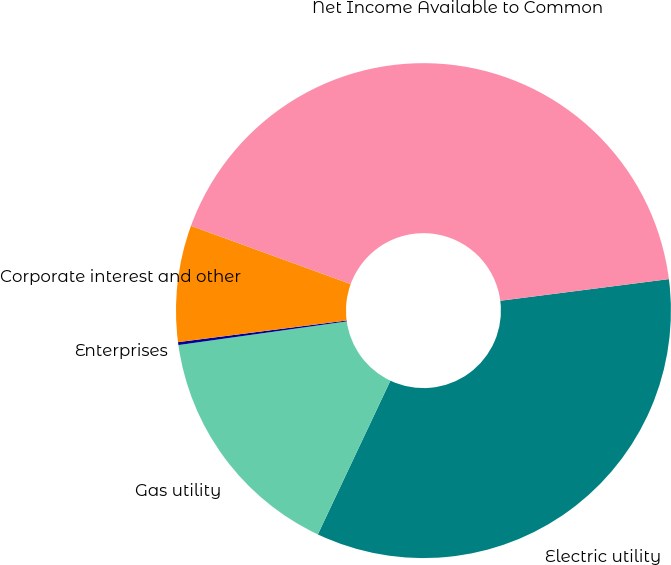Convert chart to OTSL. <chart><loc_0><loc_0><loc_500><loc_500><pie_chart><fcel>Electric utility<fcel>Gas utility<fcel>Enterprises<fcel>Corporate interest and other<fcel>Net Income Available to Common<nl><fcel>34.05%<fcel>15.76%<fcel>0.19%<fcel>7.6%<fcel>42.4%<nl></chart> 